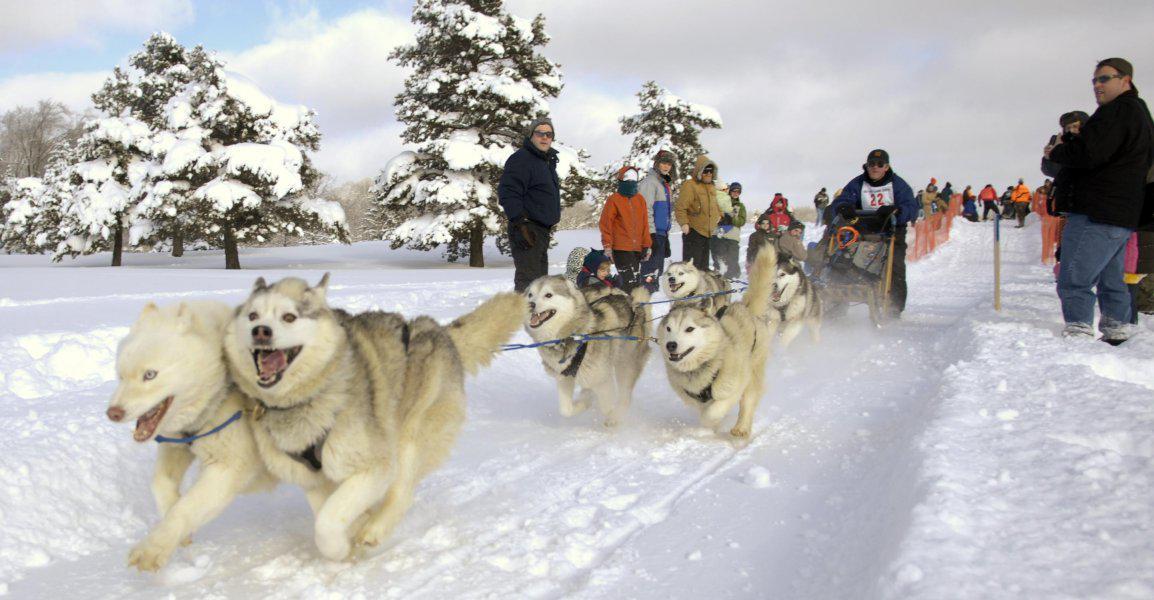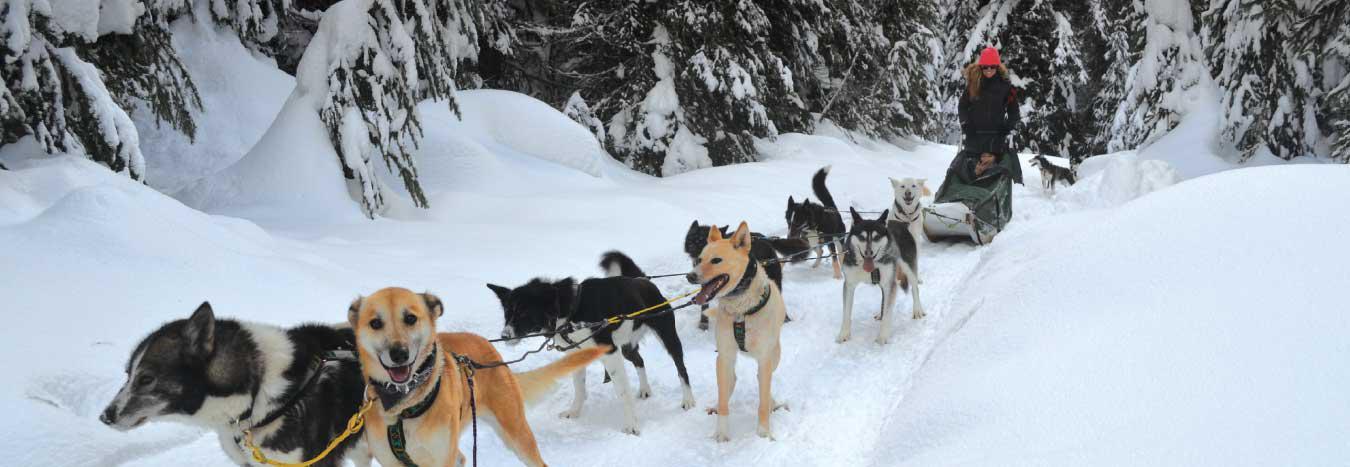The first image is the image on the left, the second image is the image on the right. Evaluate the accuracy of this statement regarding the images: "An image shows one dog team moving diagonally across the snow, with snow-covered evergreens in the background and no bystanders.". Is it true? Answer yes or no. Yes. The first image is the image on the left, the second image is the image on the right. For the images displayed, is the sentence "Someone is wearing a vest with a number in at least one of the images." factually correct? Answer yes or no. No. 